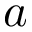Convert formula to latex. <formula><loc_0><loc_0><loc_500><loc_500>a</formula> 